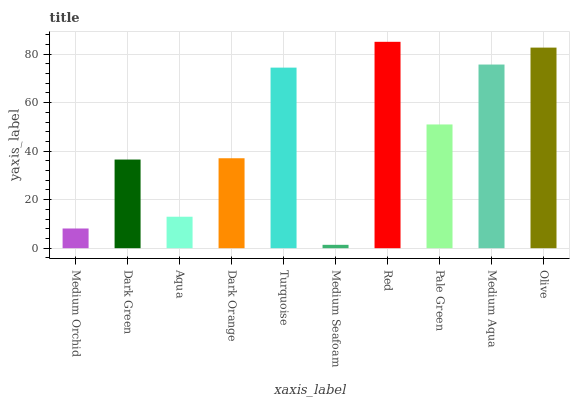Is Medium Seafoam the minimum?
Answer yes or no. Yes. Is Red the maximum?
Answer yes or no. Yes. Is Dark Green the minimum?
Answer yes or no. No. Is Dark Green the maximum?
Answer yes or no. No. Is Dark Green greater than Medium Orchid?
Answer yes or no. Yes. Is Medium Orchid less than Dark Green?
Answer yes or no. Yes. Is Medium Orchid greater than Dark Green?
Answer yes or no. No. Is Dark Green less than Medium Orchid?
Answer yes or no. No. Is Pale Green the high median?
Answer yes or no. Yes. Is Dark Orange the low median?
Answer yes or no. Yes. Is Olive the high median?
Answer yes or no. No. Is Medium Orchid the low median?
Answer yes or no. No. 